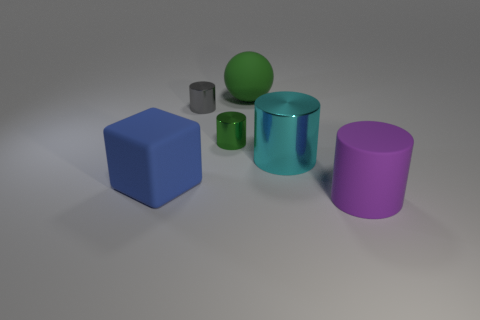Subtract all small gray shiny cylinders. How many cylinders are left? 3 Subtract all cyan cylinders. How many cylinders are left? 3 Subtract 1 cylinders. How many cylinders are left? 3 Add 2 tiny purple shiny things. How many objects exist? 8 Subtract all brown cylinders. Subtract all cyan spheres. How many cylinders are left? 4 Subtract all cylinders. How many objects are left? 2 Subtract all gray rubber balls. Subtract all big purple matte cylinders. How many objects are left? 5 Add 3 green shiny cylinders. How many green shiny cylinders are left? 4 Add 4 cyan shiny cylinders. How many cyan shiny cylinders exist? 5 Subtract 1 gray cylinders. How many objects are left? 5 